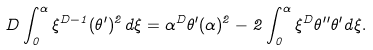<formula> <loc_0><loc_0><loc_500><loc_500>D \int _ { 0 } ^ { \alpha } \xi ^ { D - 1 } ( \theta ^ { \prime } ) ^ { 2 } d \xi = \alpha ^ { D } \theta ^ { \prime } ( \alpha ) ^ { 2 } - 2 \int _ { 0 } ^ { \alpha } \xi ^ { D } \theta ^ { \prime \prime } \theta ^ { \prime } d \xi .</formula> 